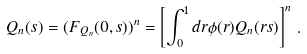<formula> <loc_0><loc_0><loc_500><loc_500>Q _ { n } ( s ) = ( F _ { Q _ { n } } ( 0 , s ) ) ^ { n } = \left [ \int _ { 0 } ^ { 1 } d r \phi ( r ) Q _ { n } ( r s ) \right ] ^ { n } \, .</formula> 